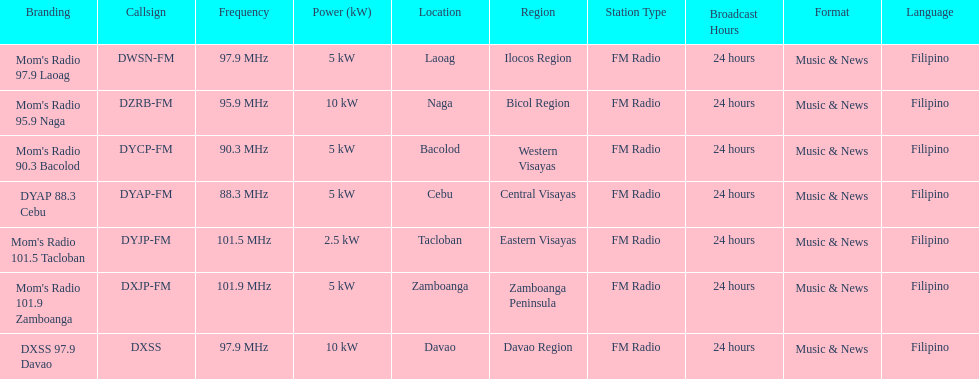How many stations have at least 5 kw or more listed in the power column? 6. 